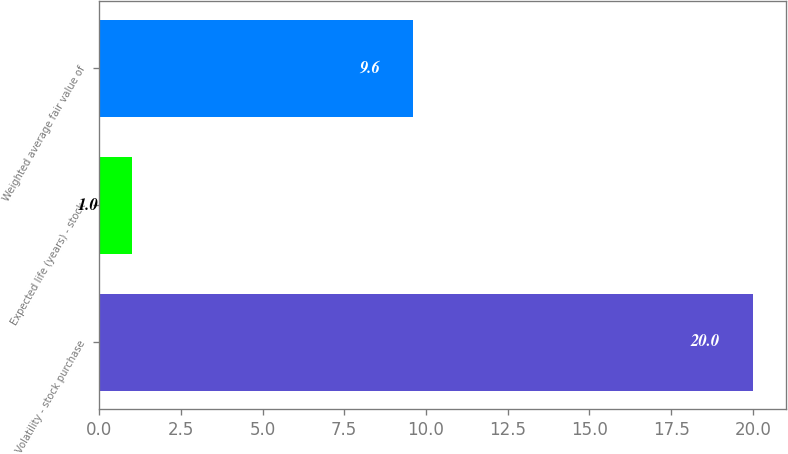<chart> <loc_0><loc_0><loc_500><loc_500><bar_chart><fcel>Volatility - stock purchase<fcel>Expected life (years) - stock<fcel>Weighted average fair value of<nl><fcel>20<fcel>1<fcel>9.6<nl></chart> 